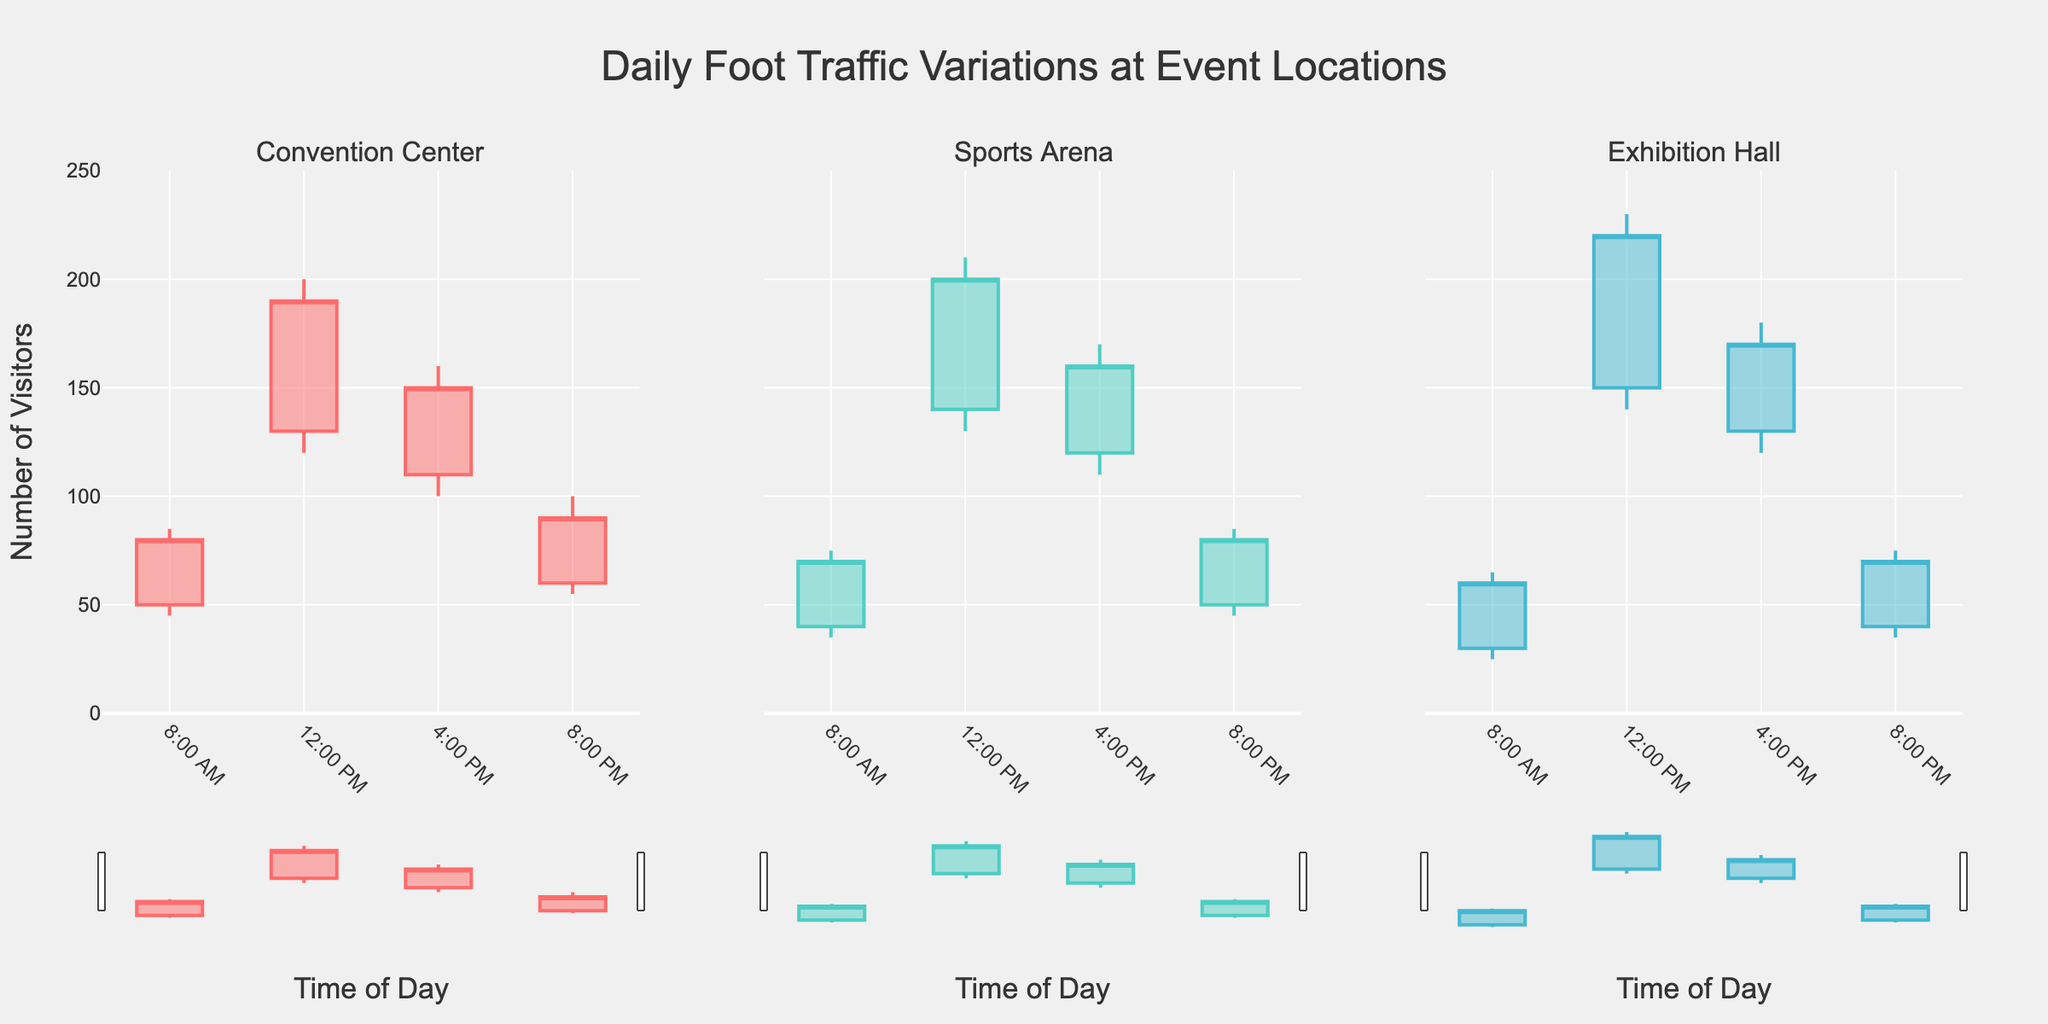What is the title of the plot? The title is usually displayed prominently at the top center of the plot. Here it's "Daily Foot Traffic Variations at Event Locations".
Answer: Daily Foot Traffic Variations at Event Locations What time of day do we observe the highest foot traffic at the Exhibition Hall? By looking at the plot for the Exhibition Hall, identify the candlestick with the highest high value. The 12:00 PM candlestick has the highest value of 230.
Answer: 12:00 PM How does the closing value at 8:00 PM at the Sports Arena compare to the opening value at 4:00 PM at the same location? Check the 8:00 PM candlestick closing value and compare it to the 4:00 PM candlestick opening value at the Sports Arena. The closing value at 8:00 PM is 80, and the opening value at 4:00 PM is 120. The closing value at 8:00 PM is lower than the opening value at 4:00 PM.
Answer: Lower Which location has the highest opening value at 12:00 PM? Review the opening values at 12:00 PM for all locations. The Exhibition Hall has the highest opening value of 150.
Answer: Exhibition Hall What is the range of foot traffic at the Convention Center at 12:00 PM? Calculate the difference between the high and low values for the 12:00 PM candlestick at the Convention Center, which are 200 and 120 respectively. The range is 200 - 120 = 80.
Answer: 80 By how much does the high of the Exhibition Hall at 4:00 PM exceed the low of the Convention Center at 4:00 PM? Determine the high value at 4:00 PM for Exhibition Hall (180) and the low value at 4:00 PM for Convention Center (100). Then, calculate the difference: 180 - 100 = 80.
Answer: 80 Which location had the most stable foot traffic at 8:00 AM, considering the smallest range between high and low values? The location with the smallest range between high and low values at 8:00 AM can be found by subtracting the low from the high for each location. Convention Center: 85-45=40, Sports Arena: 75-35=40, Exhibition Hall: 65-25=40. All three locations had the same range (40).
Answer: All three locations What is the average closing value at 12:00 PM across all locations? Sum the closing values at 12:00 PM for all locations: 190 (Convention Center) + 200 (Sports Arena) + 220 (Exhibition Hall) = 610. Then, divide by the number of locations: 610 / 3 = 203.3.
Answer: 203.3 Compare the variation in foot traffic at 4:00 PM between the Sports Arena and the Exhibition Hall. Which one showed greater variability? Compare the range (high minus low) for each. Sports Arena: 170-110=60, Exhibition Hall: 180-120=60. Both show equal variability.
Answer: Equal 